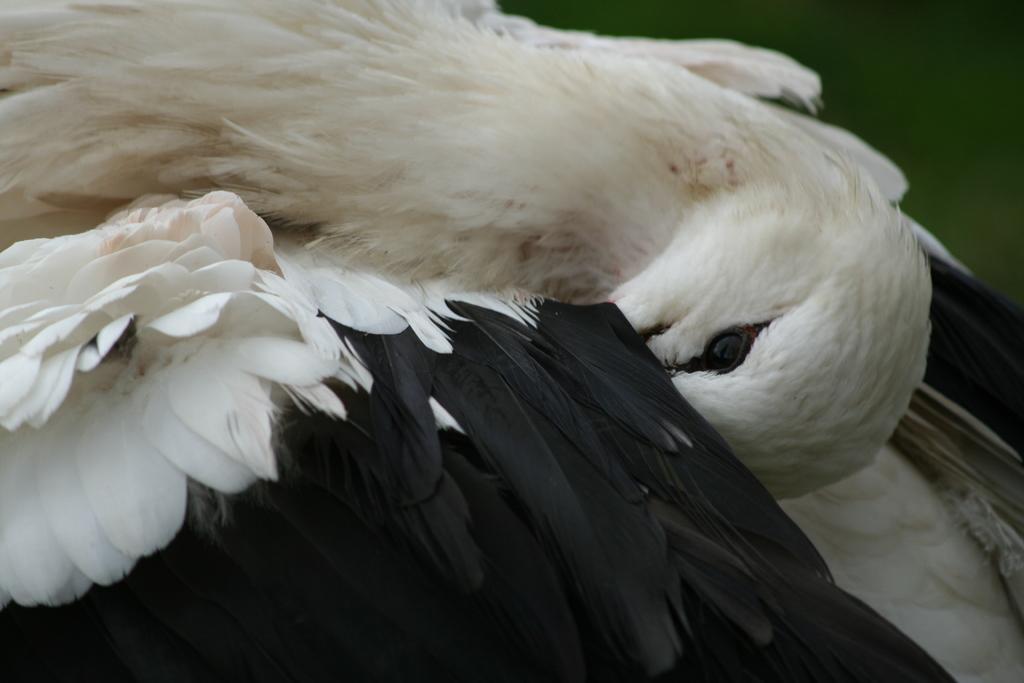What type of animal can be seen in the image? There is a bird in the image. Can you describe the bird's appearance or behavior in the image? Unfortunately, the provided facts do not give any information about the bird's appearance or behavior. Where is the cave located in the image? There is no cave present in the image; it only features a bird. 